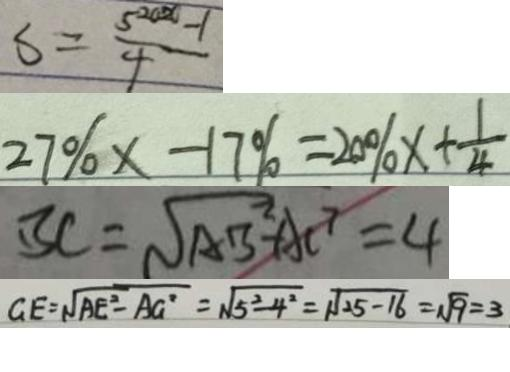Convert formula to latex. <formula><loc_0><loc_0><loc_500><loc_500>S = \frac { 5 ^ { 2 0 x } - 1 } { 4 } 
 2 7 \% x - 1 7 \% = 2 0 \% x + \frac { 1 } { 4 } 
 B C = \sqrt { A B ^ { 2 } } - A C ^ { 7 } = 4 
 G E = \sqrt { A E ^ { 2 } - A G ^ { 2 } } = \sqrt { 5 ^ { 2 } - 4 ^ { 2 } } = \sqrt { 2 5 - 1 6 } = \sqrt { 9 } = 3</formula> 